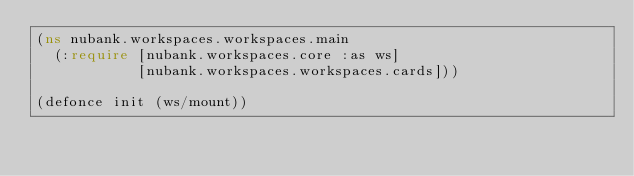Convert code to text. <code><loc_0><loc_0><loc_500><loc_500><_Clojure_>(ns nubank.workspaces.workspaces.main
  (:require [nubank.workspaces.core :as ws]
            [nubank.workspaces.workspaces.cards]))

(defonce init (ws/mount))
</code> 